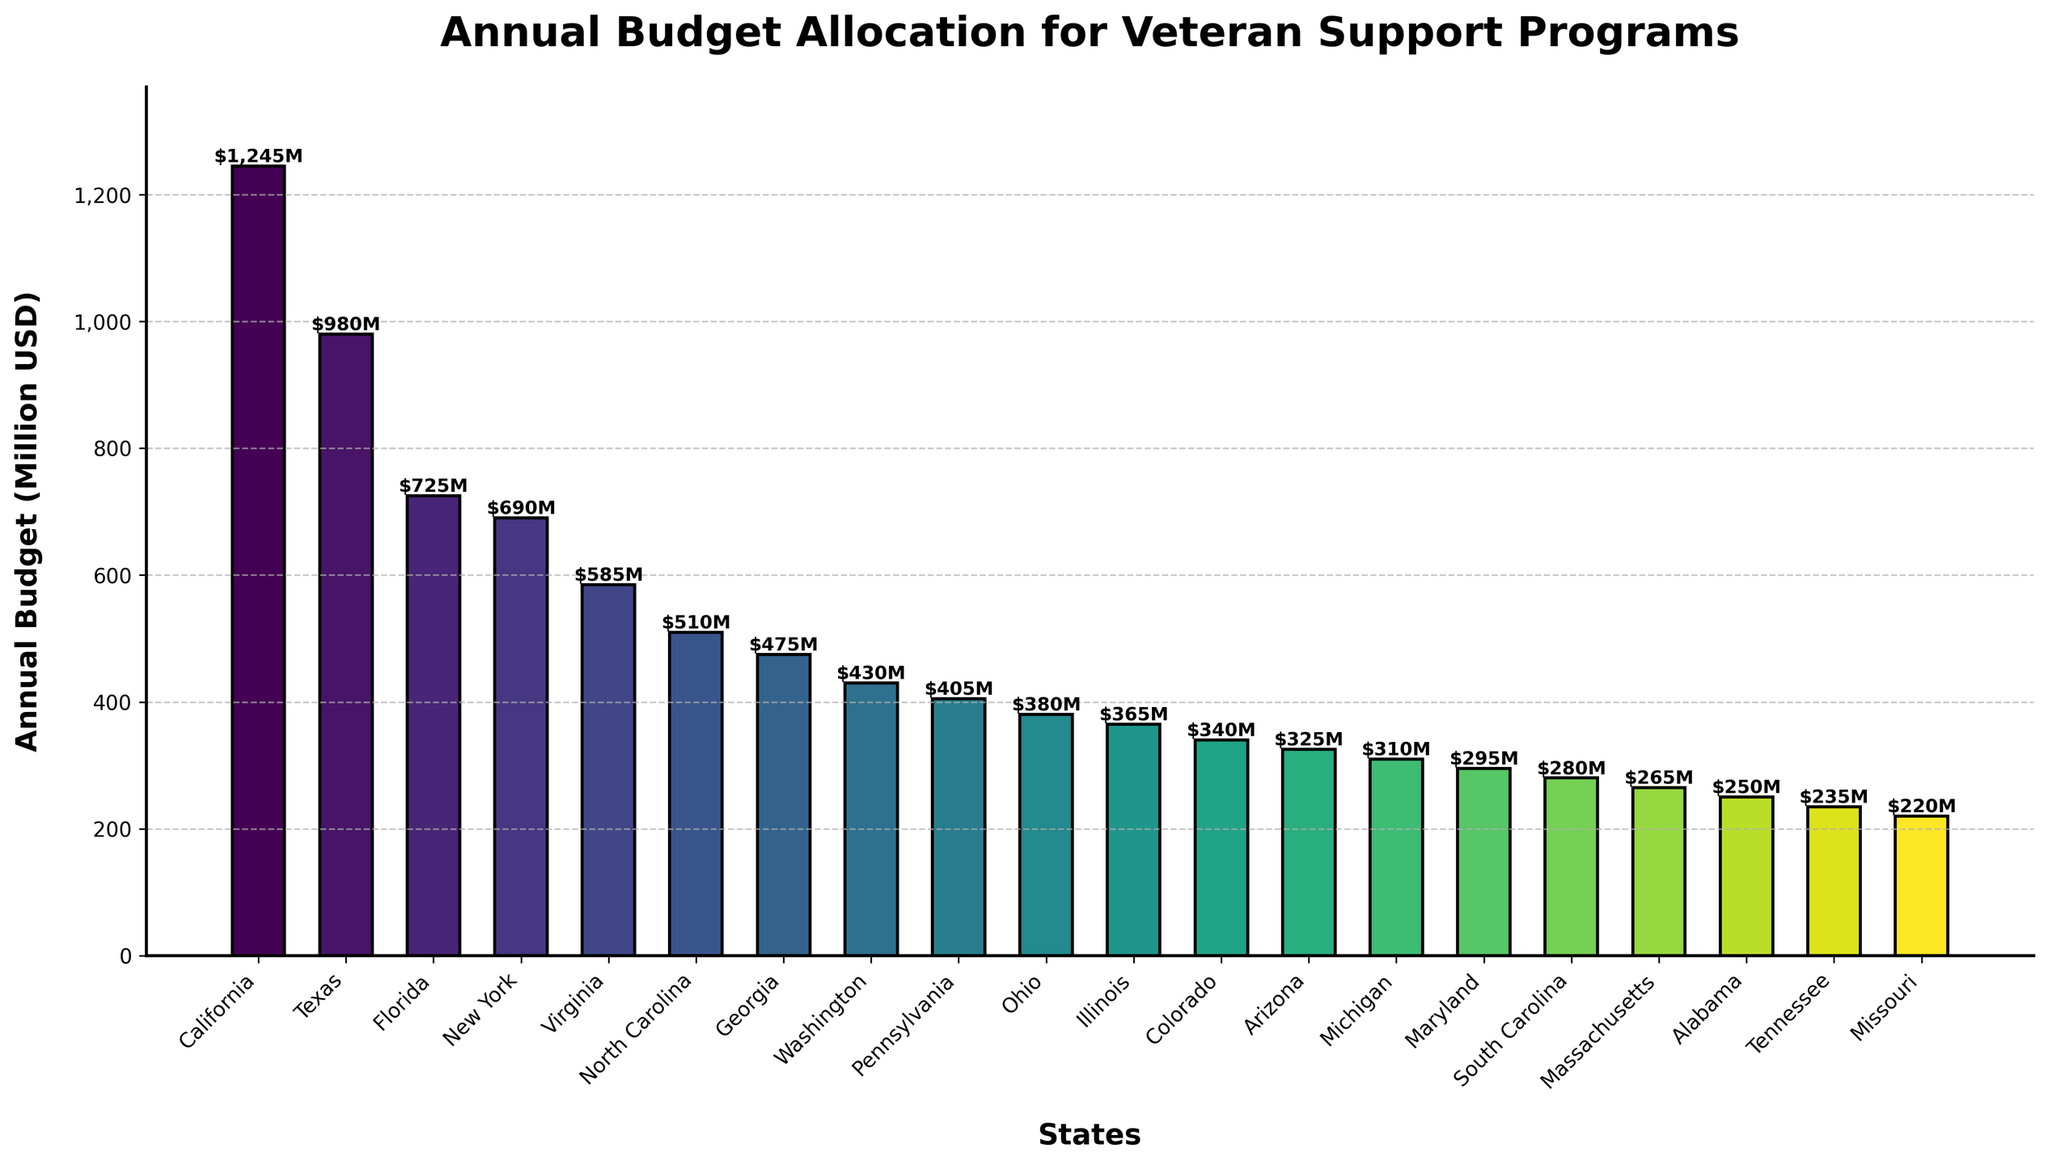What is the state with the highest annual budget allocation for veteran support programs? To find the state with the highest annual budget allocation, look at the tallest bar in the chart, which represents the highest value. The bar for California is the tallest.
Answer: California What is the combined budget allocation for Texas and Florida? Find the heights of the bars for Texas and Florida. Texas has a budget of 980 million USD, and Florida has 725 million USD. Add these values together: 980 + 725 = 1705.
Answer: 1705 million USD Which states have a budget allocation greater than 500 million USD? Identify the bars that are taller than the 500 million USD mark. The states are California, Texas, Florida, New York, and Virginia.
Answer: California, Texas, Florida, New York, Virginia How does the budget allocation for Ohio compare to Illinois? Check the heights of the bars for Ohio and Illinois. Ohio has a budget of 380 million USD and Illinois has 365 million USD. Compare these values: 380 is greater than 365.
Answer: Ohio has a higher budget than Illinois What is the average budget allocation for the top 5 states? Identify the top 5 states with the highest budgets: California (1245), Texas (980), Florida (725), New York (690), Virginia (585). Add these values together and divide by 5: (1245 + 980 + 725 + 690 + 585) / 5 = 845.
Answer: 845 million USD Which states have a budget allocation less than 300 million USD? Identify the bars that are shorter than the 300 million USD mark. The states are Maryland, South Carolina, Massachusetts, Alabama, Tennessee, and Missouri.
Answer: Maryland, South Carolina, Massachusetts, Alabama, Tennessee, Missouri What is the total budget allocation for all states combined? Add up the budget values for all 20 states. The total is: 1245 + 980 + 725 + 690 + 585 + 510 + 475 + 430 + 405 + 380 + 365 + 340 + 325 + 310 + 295 + 280 + 265 + 250 + 235 + 220 = 9310.
Answer: 9310 million USD How much more does California allocate compared to Georgia? Find the budget values for California and Georgia. Subtract Georgia's budget from California's: 1245 - 475 = 770.
Answer: 770 million USD Which state has the lowest annual budget allocation for veteran support programs? Identify the shortest bar in the chart, which represents the lowest value. The bar for Missouri is the shortest.
Answer: Missouri What is the median budget allocation for all states? List all budget values in ascending order and find the middle value. Ordered budgets: 220, 235, 250, 265, 280, 295, 310, 325, 340, 365, 380, 405, 430, 475, 510, 585, 690, 725, 980, 1245. The median is the average of the 10th and 11th values: (365 + 380) / 2 = 372.5.
Answer: 372.5 million USD 